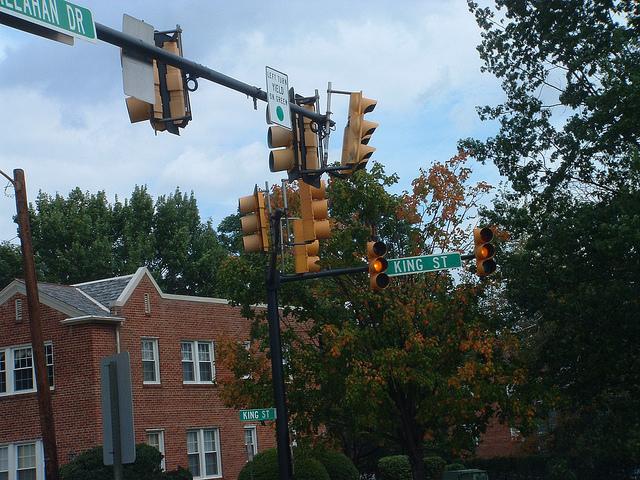What is this house made of?
Write a very short answer. Brick. Where is this house located?
Give a very brief answer. King st. What is the street's name?
Give a very brief answer. King st. What color light is lit on the traffic light?
Write a very short answer. Yellow. What color are most of the buildings?
Keep it brief. Red. Is this an urban or rural location?
Short answer required. Rural. What type of houses are in the background?
Write a very short answer. Brick. 